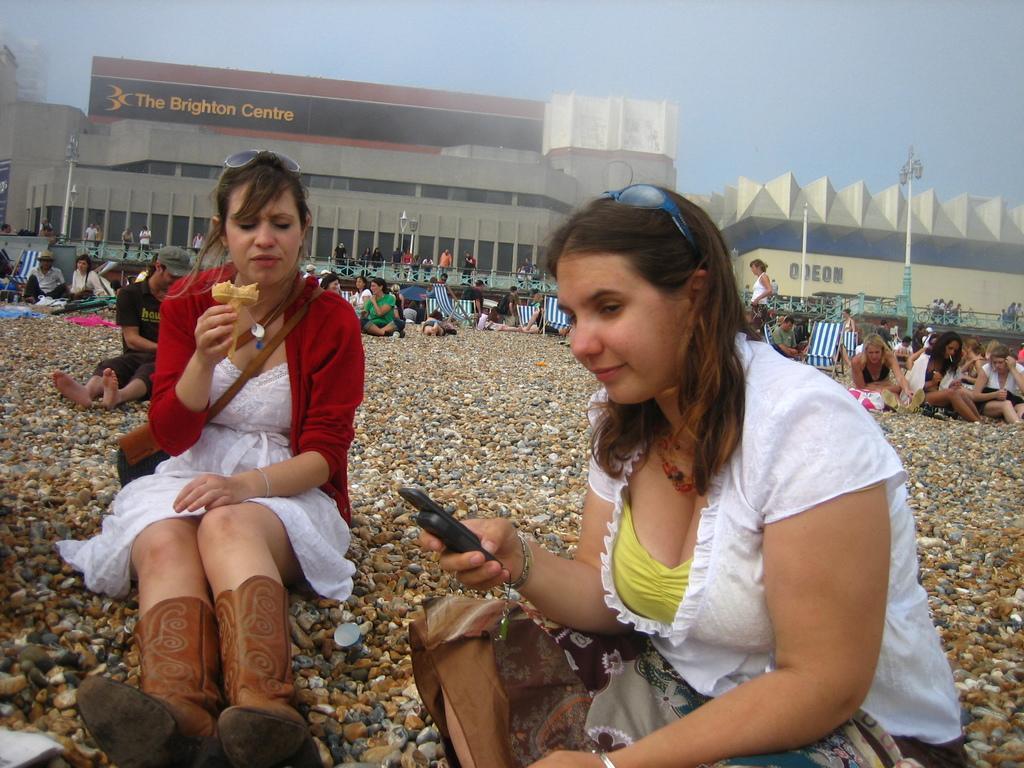Describe this image in one or two sentences. In this image we can see two women are sitting on the floor. One woman is wearing white and yellow color top and holding mobile in her hand. The other one is wearing white dress with red shrug and she is holding ice cream in her hand. Behind them so many people are sitting and chilling out, behind the people two buildings are there. 